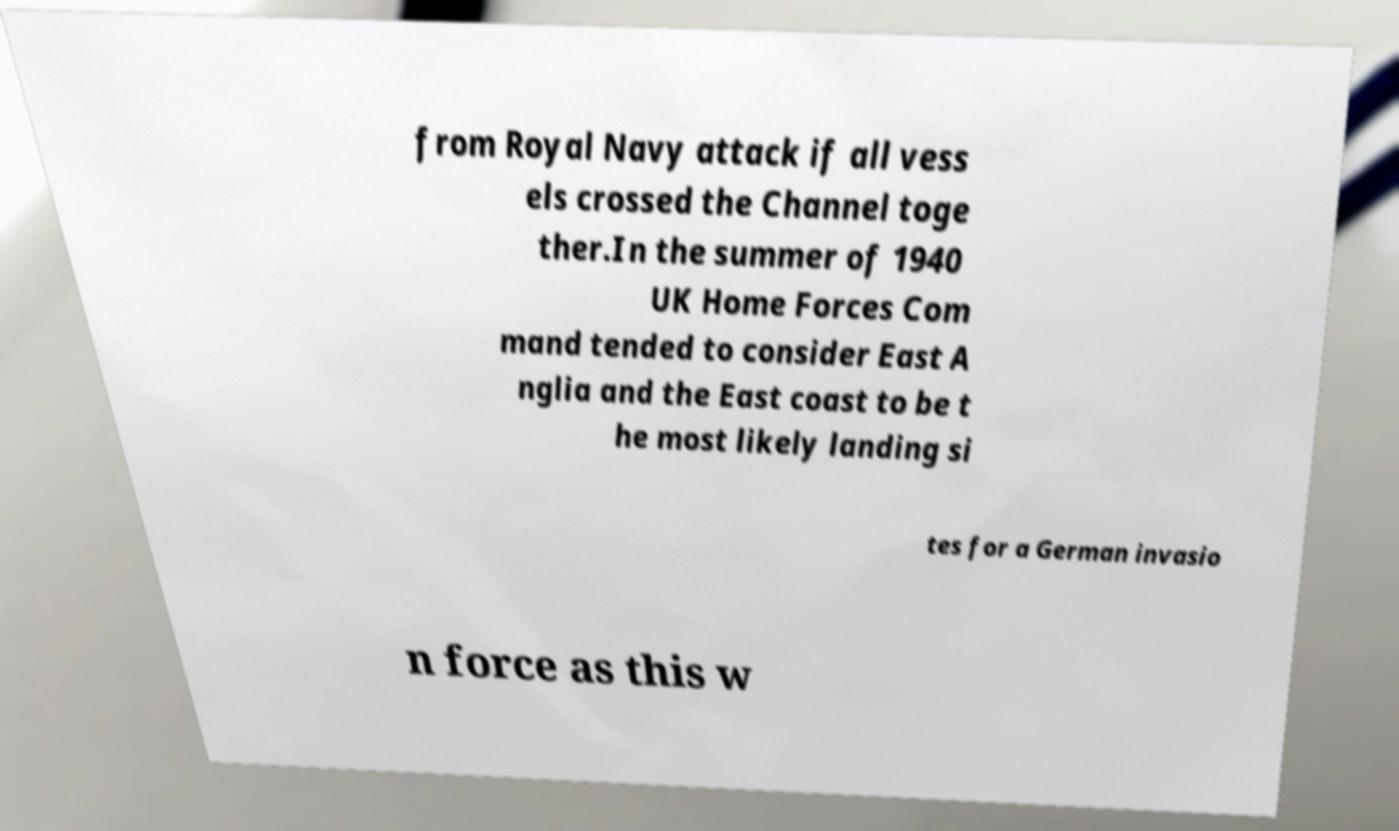For documentation purposes, I need the text within this image transcribed. Could you provide that? from Royal Navy attack if all vess els crossed the Channel toge ther.In the summer of 1940 UK Home Forces Com mand tended to consider East A nglia and the East coast to be t he most likely landing si tes for a German invasio n force as this w 